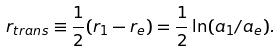Convert formula to latex. <formula><loc_0><loc_0><loc_500><loc_500>r _ { t r a n s } \equiv \frac { 1 } { 2 } ( r _ { 1 } - r _ { e } ) = \frac { 1 } { 2 } \ln ( a _ { 1 } / a _ { e } ) .</formula> 